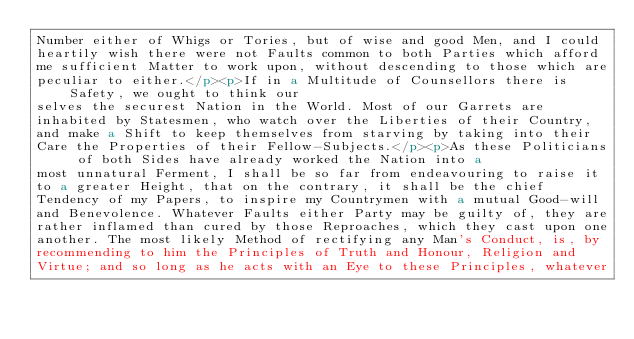Convert code to text. <code><loc_0><loc_0><loc_500><loc_500><_HTML_>Number either of Whigs or Tories, but of wise and good Men, and I could
heartily wish there were not Faults common to both Parties which afford
me sufficient Matter to work upon, without descending to those which are
peculiar to either.</p><p>If in a Multitude of Counsellors there is Safety, we ought to think our
selves the securest Nation in the World. Most of our Garrets are
inhabited by Statesmen, who watch over the Liberties of their Country,
and make a Shift to keep themselves from starving by taking into their
Care the Properties of their Fellow-Subjects.</p><p>As these Politicians of both Sides have already worked the Nation into a
most unnatural Ferment, I shall be so far from endeavouring to raise it
to a greater Height, that on the contrary, it shall be the chief
Tendency of my Papers, to inspire my Countrymen with a mutual Good-will
and Benevolence. Whatever Faults either Party may be guilty of, they are
rather inflamed than cured by those Reproaches, which they cast upon one
another. The most likely Method of rectifying any Man's Conduct, is, by
recommending to him the Principles of Truth and Honour, Religion and
Virtue; and so long as he acts with an Eye to these Principles, whatever</code> 